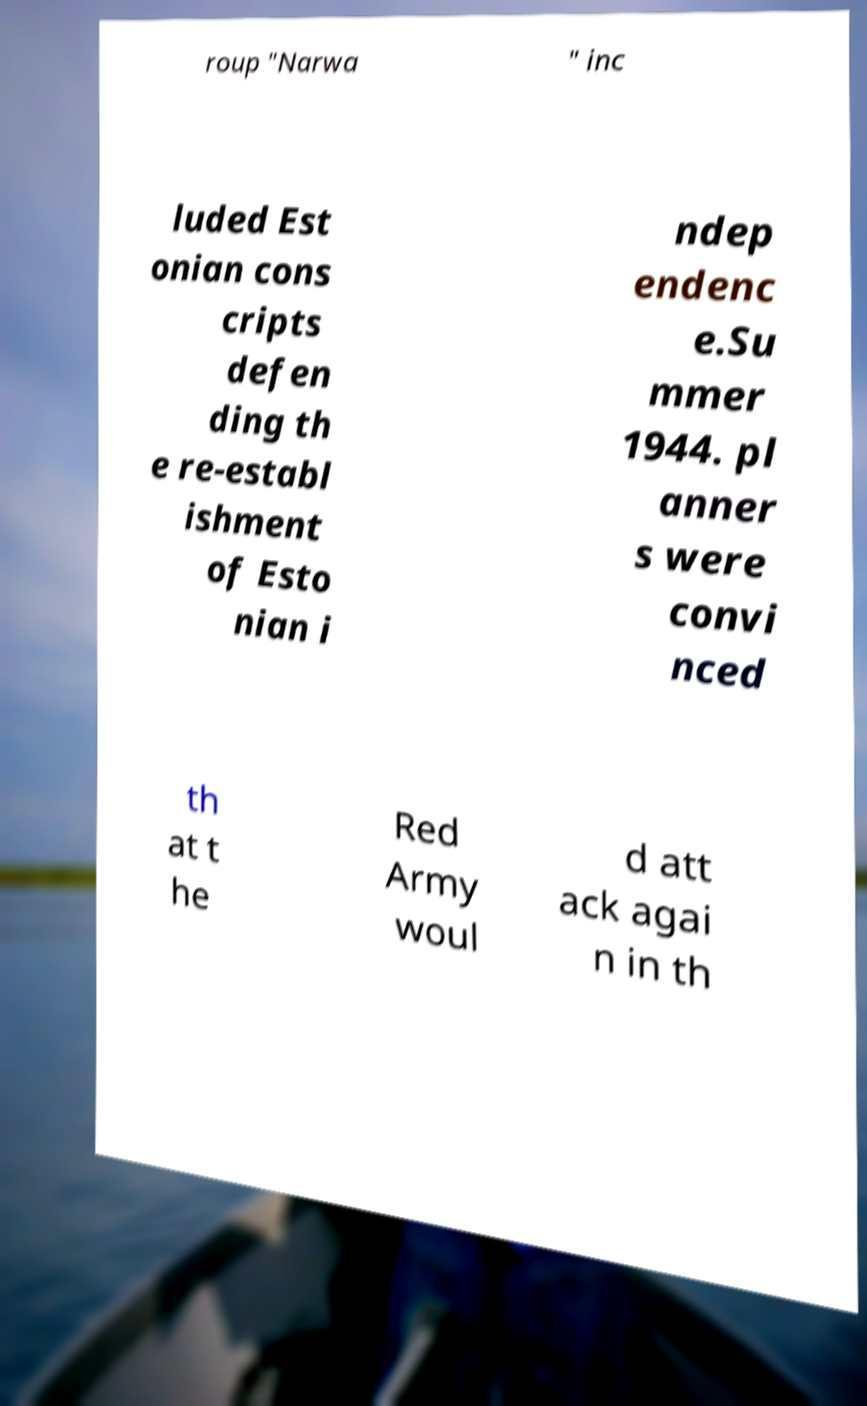Can you accurately transcribe the text from the provided image for me? roup "Narwa " inc luded Est onian cons cripts defen ding th e re-establ ishment of Esto nian i ndep endenc e.Su mmer 1944. pl anner s were convi nced th at t he Red Army woul d att ack agai n in th 